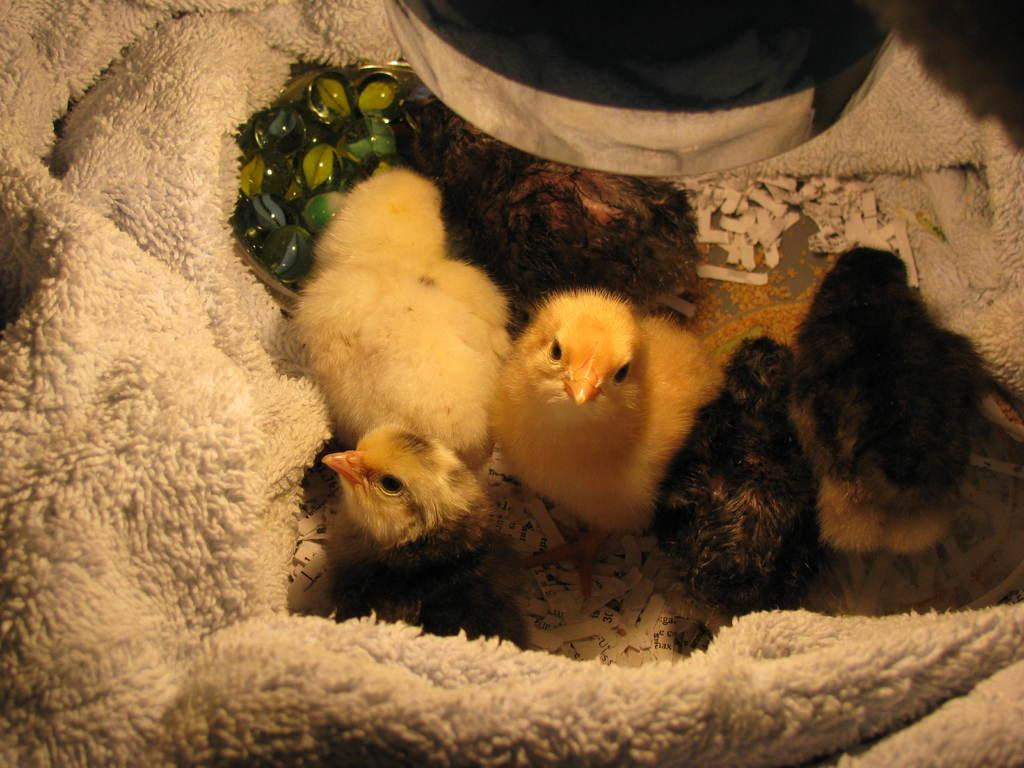What type of animals are present in the image? There are chicken little's in the image. Can you describe the appearance of the chicken little's? The chicken little's have different colors. What is surrounding the chicken little's in the image? The chicken little's are surrounded by a cloth. How many teeth can be seen on the chicken little's in the image? Chicken little's do not have teeth, so none can be seen in the image. 